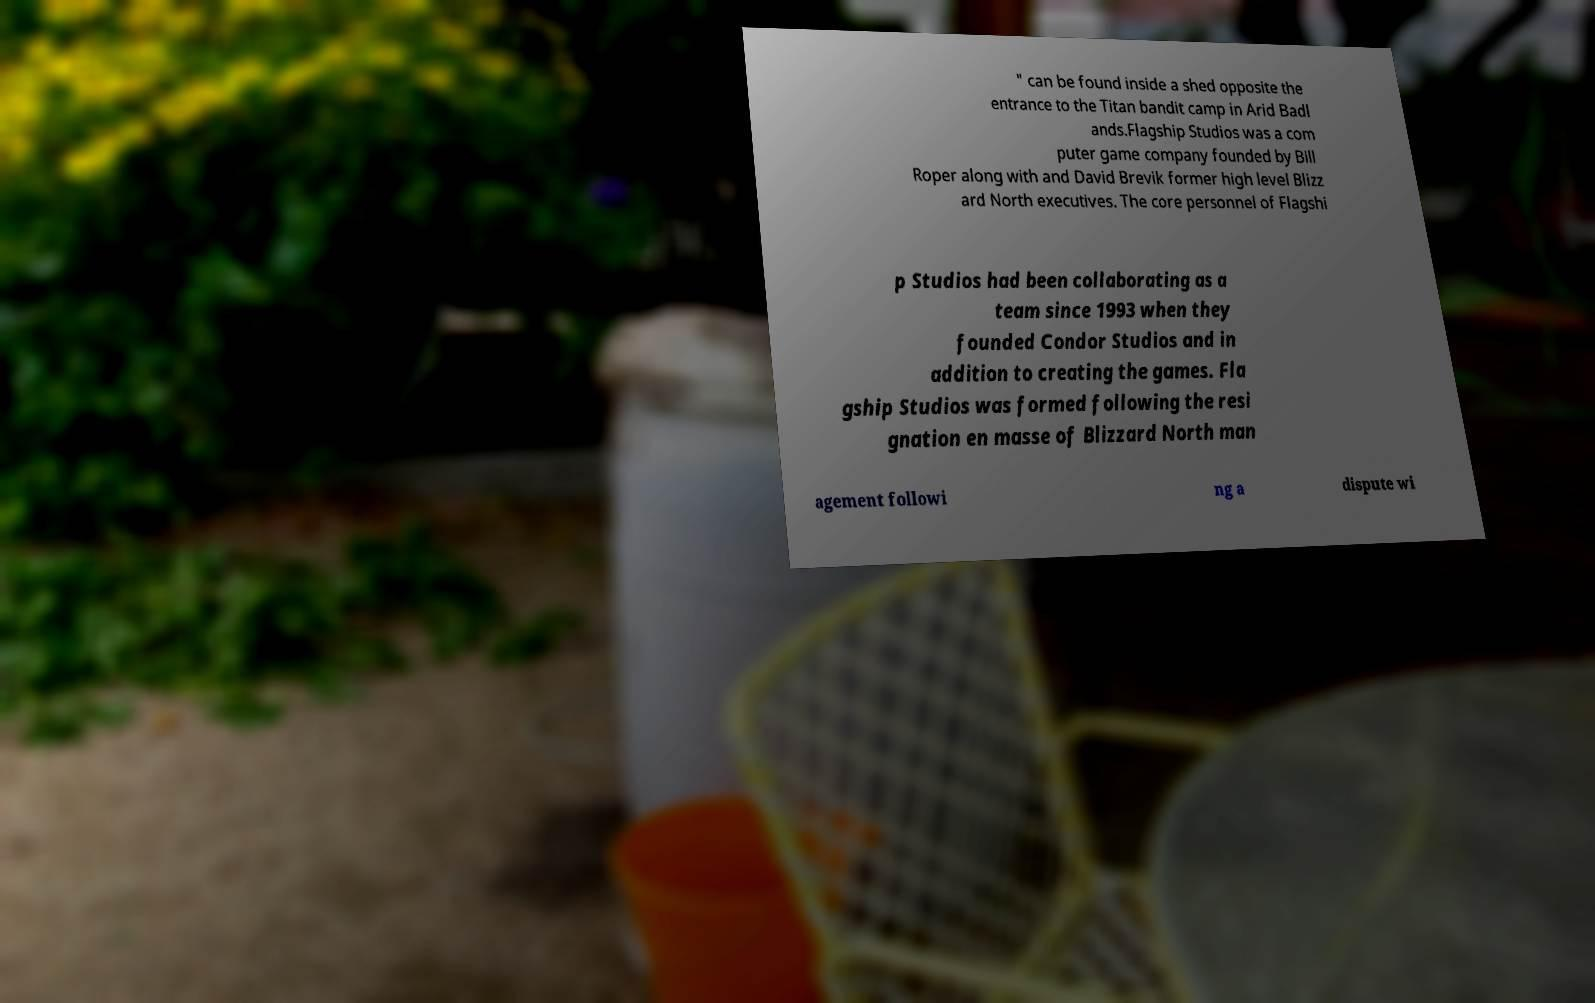Please identify and transcribe the text found in this image. " can be found inside a shed opposite the entrance to the Titan bandit camp in Arid Badl ands.Flagship Studios was a com puter game company founded by Bill Roper along with and David Brevik former high level Blizz ard North executives. The core personnel of Flagshi p Studios had been collaborating as a team since 1993 when they founded Condor Studios and in addition to creating the games. Fla gship Studios was formed following the resi gnation en masse of Blizzard North man agement followi ng a dispute wi 